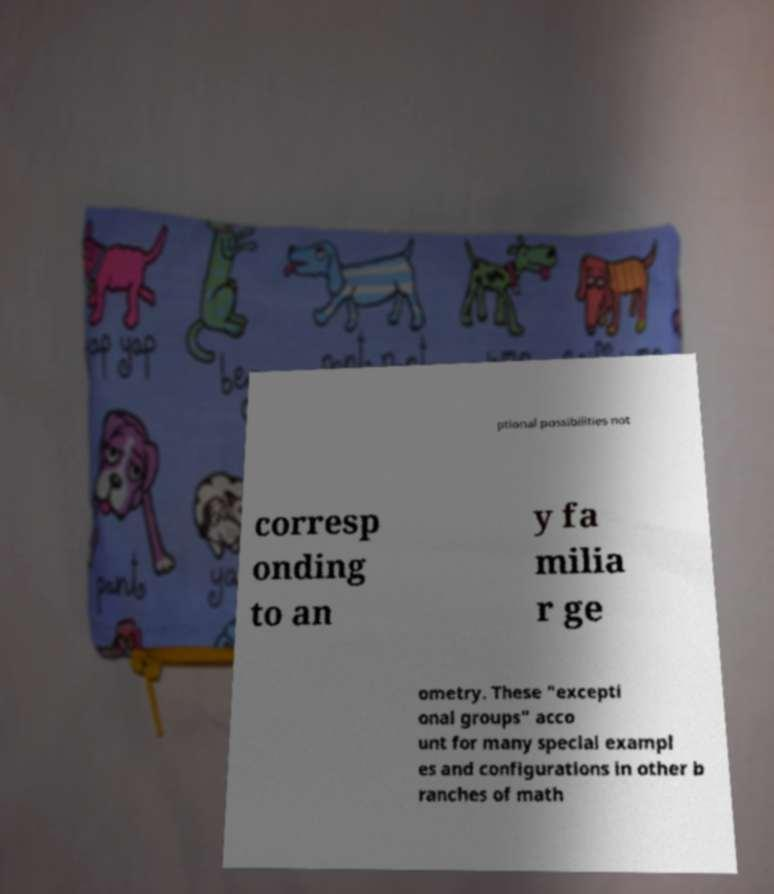I need the written content from this picture converted into text. Can you do that? ptional possibilities not corresp onding to an y fa milia r ge ometry. These "excepti onal groups" acco unt for many special exampl es and configurations in other b ranches of math 